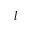<formula> <loc_0><loc_0><loc_500><loc_500>l</formula> 